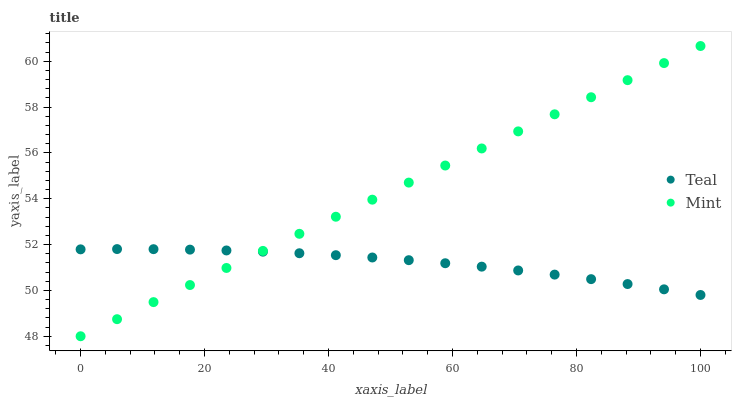Does Teal have the minimum area under the curve?
Answer yes or no. Yes. Does Mint have the maximum area under the curve?
Answer yes or no. Yes. Does Teal have the maximum area under the curve?
Answer yes or no. No. Is Mint the smoothest?
Answer yes or no. Yes. Is Teal the roughest?
Answer yes or no. Yes. Is Teal the smoothest?
Answer yes or no. No. Does Mint have the lowest value?
Answer yes or no. Yes. Does Teal have the lowest value?
Answer yes or no. No. Does Mint have the highest value?
Answer yes or no. Yes. Does Teal have the highest value?
Answer yes or no. No. Does Teal intersect Mint?
Answer yes or no. Yes. Is Teal less than Mint?
Answer yes or no. No. Is Teal greater than Mint?
Answer yes or no. No. 